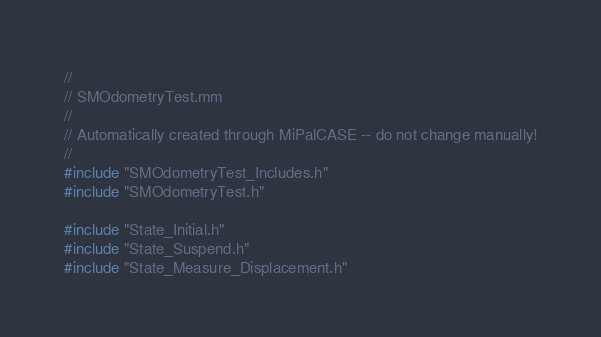<code> <loc_0><loc_0><loc_500><loc_500><_ObjectiveC_>//
// SMOdometryTest.mm
//
// Automatically created through MiPalCASE -- do not change manually!
//
#include "SMOdometryTest_Includes.h"
#include "SMOdometryTest.h"

#include "State_Initial.h"
#include "State_Suspend.h"
#include "State_Measure_Displacement.h"</code> 